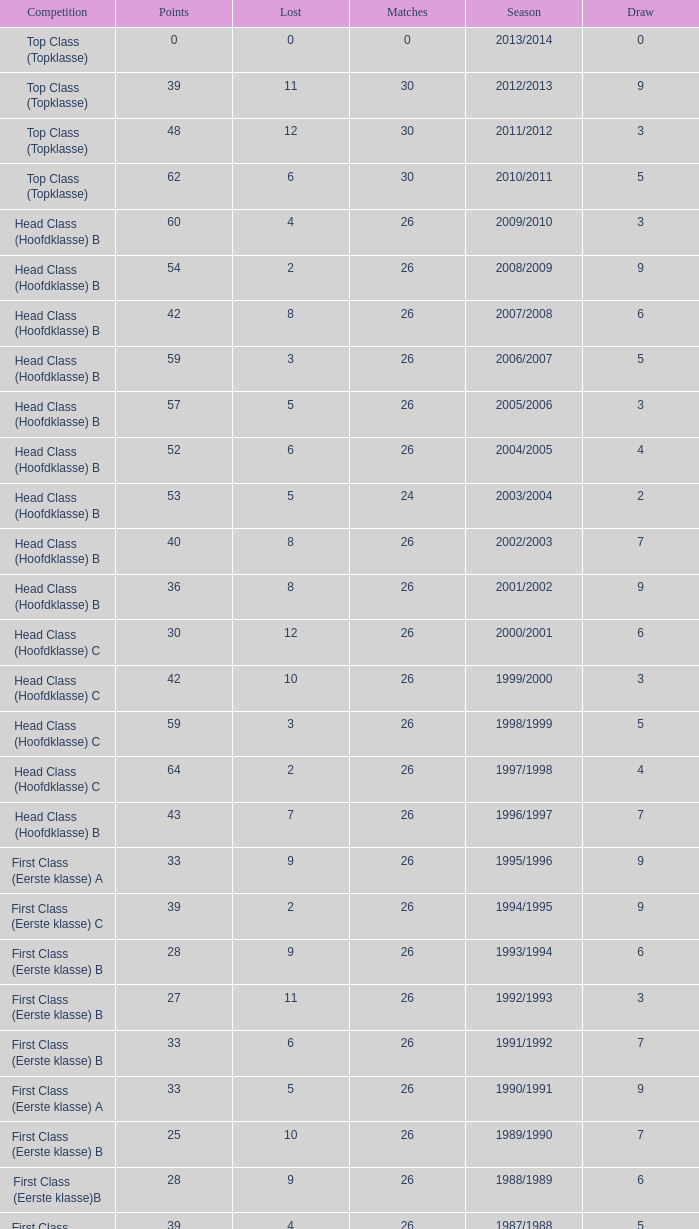What competition has a score greater than 30, a draw less than 5, and a loss larger than 10? Top Class (Topklasse). 